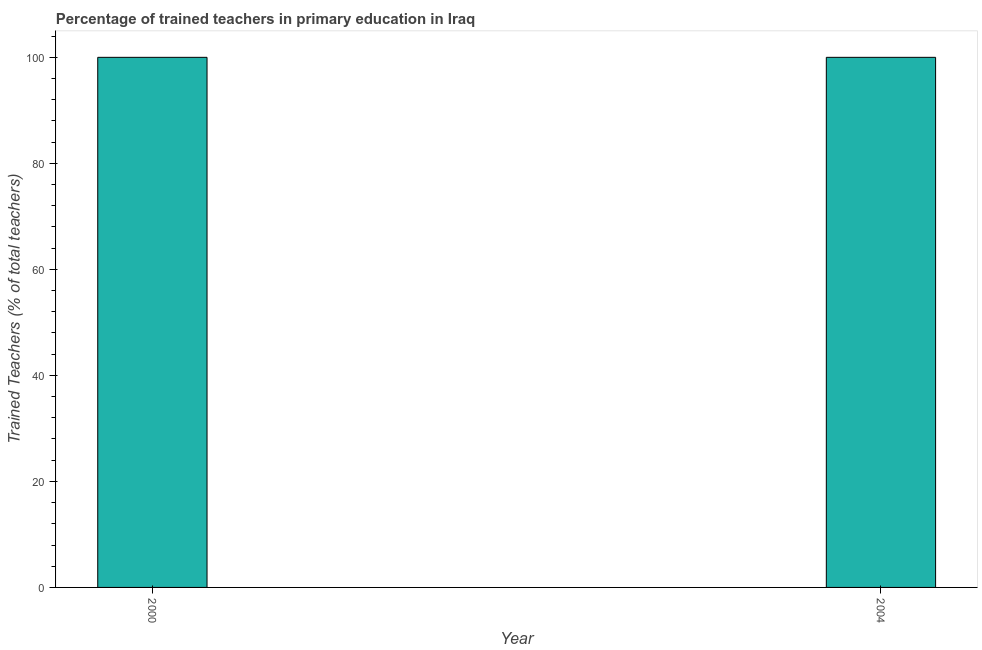What is the title of the graph?
Provide a short and direct response. Percentage of trained teachers in primary education in Iraq. What is the label or title of the X-axis?
Provide a short and direct response. Year. What is the label or title of the Y-axis?
Make the answer very short. Trained Teachers (% of total teachers). Across all years, what is the minimum percentage of trained teachers?
Make the answer very short. 100. In which year was the percentage of trained teachers minimum?
Give a very brief answer. 2000. What is the sum of the percentage of trained teachers?
Ensure brevity in your answer.  200. What is the average percentage of trained teachers per year?
Ensure brevity in your answer.  100. In how many years, is the percentage of trained teachers greater than 16 %?
Offer a terse response. 2. Do a majority of the years between 2000 and 2004 (inclusive) have percentage of trained teachers greater than 24 %?
Make the answer very short. Yes. In how many years, is the percentage of trained teachers greater than the average percentage of trained teachers taken over all years?
Give a very brief answer. 0. How many bars are there?
Your response must be concise. 2. Are all the bars in the graph horizontal?
Your answer should be compact. No. What is the difference between two consecutive major ticks on the Y-axis?
Offer a terse response. 20. What is the Trained Teachers (% of total teachers) in 2000?
Your answer should be very brief. 100. What is the ratio of the Trained Teachers (% of total teachers) in 2000 to that in 2004?
Ensure brevity in your answer.  1. 